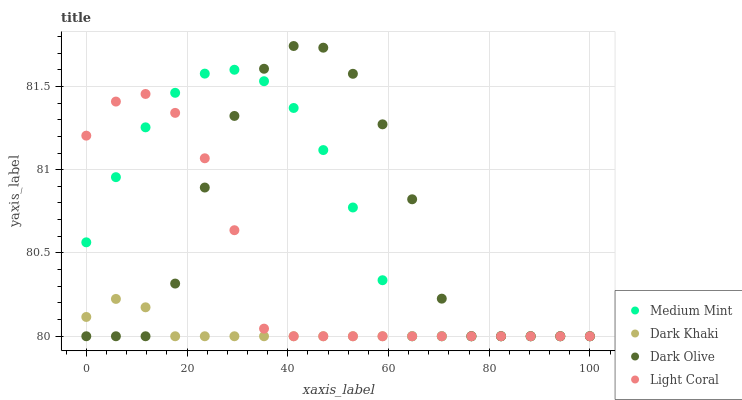Does Dark Khaki have the minimum area under the curve?
Answer yes or no. Yes. Does Medium Mint have the maximum area under the curve?
Answer yes or no. Yes. Does Dark Olive have the minimum area under the curve?
Answer yes or no. No. Does Dark Olive have the maximum area under the curve?
Answer yes or no. No. Is Dark Khaki the smoothest?
Answer yes or no. Yes. Is Dark Olive the roughest?
Answer yes or no. Yes. Is Dark Olive the smoothest?
Answer yes or no. No. Is Dark Khaki the roughest?
Answer yes or no. No. Does Medium Mint have the lowest value?
Answer yes or no. Yes. Does Dark Olive have the highest value?
Answer yes or no. Yes. Does Dark Khaki have the highest value?
Answer yes or no. No. Does Dark Olive intersect Medium Mint?
Answer yes or no. Yes. Is Dark Olive less than Medium Mint?
Answer yes or no. No. Is Dark Olive greater than Medium Mint?
Answer yes or no. No. 